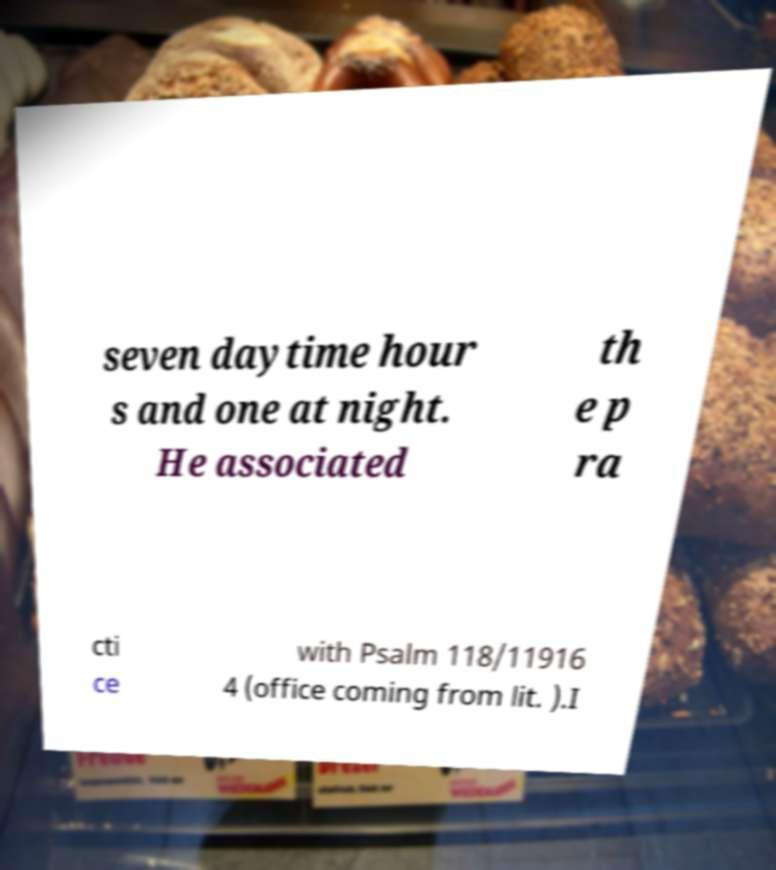Could you assist in decoding the text presented in this image and type it out clearly? seven daytime hour s and one at night. He associated th e p ra cti ce with Psalm 118/11916 4 (office coming from lit. ).I 